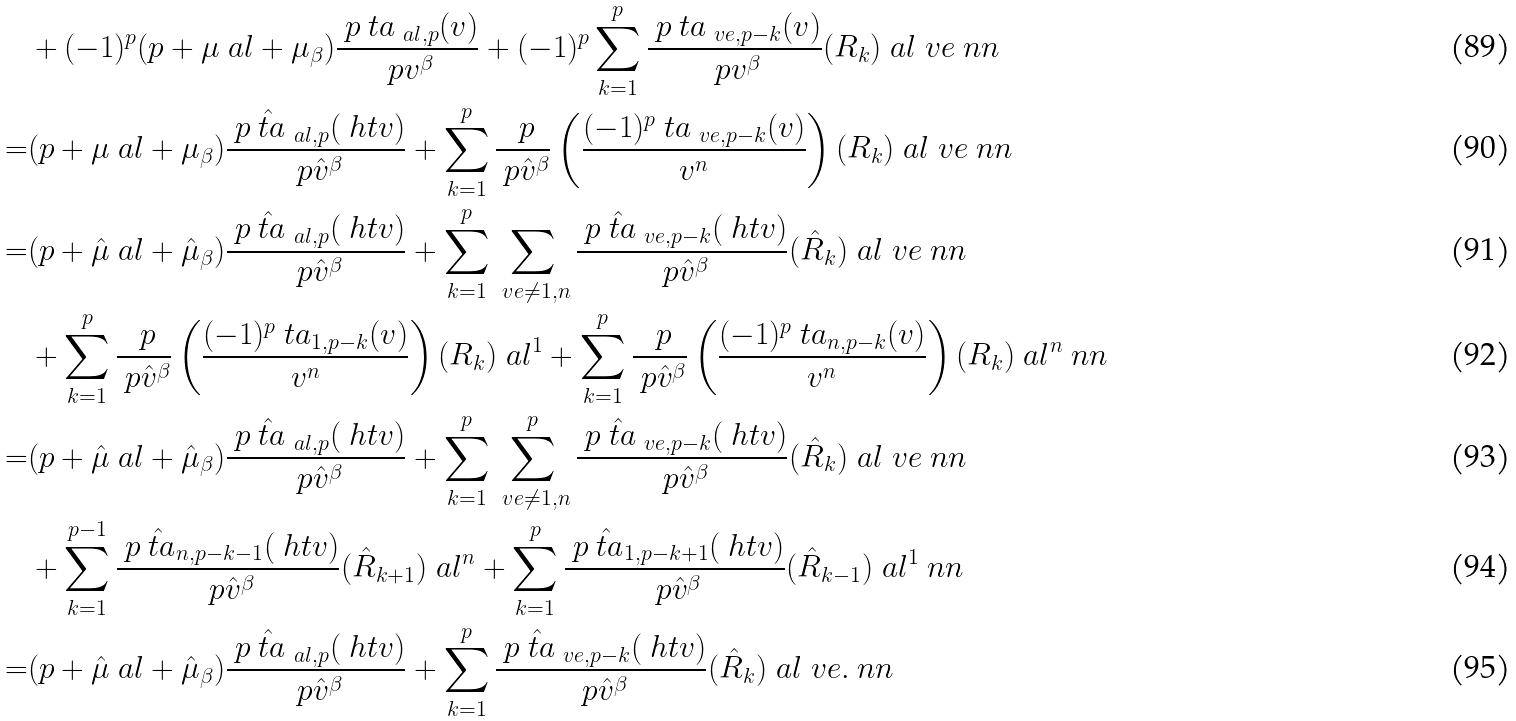Convert formula to latex. <formula><loc_0><loc_0><loc_500><loc_500>& + ( - 1 ) ^ { p } ( p + \mu _ { \ } a l + \mu _ { \beta } ) \frac { \ p \ t a _ { \ a l , p } ( v ) } { \ p v ^ { \beta } } + ( - 1 ) ^ { p } \sum _ { k = 1 } ^ { p } \frac { \ p \ t a _ { \ v e , p - k } ( v ) } { \ p v ^ { \beta } } ( R _ { k } ) _ { \ } a l ^ { \ } v e \ n n \\ = & ( p + \mu _ { \ } a l + \mu _ { \beta } ) \frac { \ p \hat { \ t a } _ { \ a l , p } ( \ h t v ) } { \ p \hat { v } ^ { \beta } } + \sum _ { k = 1 } ^ { p } \frac { \ p } { \ p \hat { v } ^ { \beta } } \left ( \frac { ( - 1 ) ^ { p } \ t a _ { \ v e , p - k } ( v ) } { v ^ { n } } \right ) ( R _ { k } ) _ { \ } a l ^ { \ } v e \ n n \\ = & ( p + \hat { \mu } _ { \ } a l + \hat { \mu } _ { \beta } ) \frac { \ p \hat { \ t a } _ { \ a l , p } ( \ h t v ) } { \ p \hat { v } ^ { \beta } } + \sum _ { k = 1 } ^ { p } \sum _ { \ v e \neq 1 , n } \frac { \ p \hat { \ t a } _ { \ v e , p - k } ( \ h t v ) } { \ p \hat { v } ^ { \beta } } ( \hat { R } _ { k } ) _ { \ } a l ^ { \ } v e \ n n \\ & + \sum _ { k = 1 } ^ { p } \frac { \ p } { \ p \hat { v } ^ { \beta } } \left ( \frac { ( - 1 ) ^ { p } \ t a _ { 1 , p - k } ( v ) } { v ^ { n } } \right ) ( R _ { k } ) _ { \ } a l ^ { 1 } + \sum _ { k = 1 } ^ { p } \frac { \ p } { \ p \hat { v } ^ { \beta } } \left ( \frac { ( - 1 ) ^ { p } \ t a _ { n , p - k } ( v ) } { v ^ { n } } \right ) ( R _ { k } ) _ { \ } a l ^ { n } \ n n \\ = & ( p + \hat { \mu } _ { \ } a l + \hat { \mu } _ { \beta } ) \frac { \ p \hat { \ t a } _ { \ a l , p } ( \ h t v ) } { \ p \hat { v } ^ { \beta } } + \sum _ { k = 1 } ^ { p } \sum _ { \ v e \neq 1 , n } ^ { p } \frac { \ p \hat { \ t a } _ { \ v e , p - k } ( \ h t v ) } { \ p \hat { v } ^ { \beta } } ( \hat { R } _ { k } ) _ { \ } a l ^ { \ } v e \ n n \\ & + \sum _ { k = 1 } ^ { p - 1 } \frac { \ p \hat { \ t a } _ { n , p - k - 1 } ( \ h t v ) } { \ p \hat { v } ^ { \beta } } ( \hat { R } _ { k + 1 } ) _ { \ } a l ^ { n } + \sum _ { k = 1 } ^ { p } \frac { \ p \hat { \ t a } _ { 1 , p - k + 1 } ( \ h t v ) } { \ p \hat { v } ^ { \beta } } ( \hat { R } _ { k - 1 } ) _ { \ } a l ^ { 1 } \ n n \\ = & ( p + \hat { \mu } _ { \ } a l + \hat { \mu } _ { \beta } ) \frac { \ p \hat { \ t a } _ { \ a l , p } ( \ h t v ) } { \ p \hat { v } ^ { \beta } } + \sum _ { k = 1 } ^ { p } \frac { \ p \hat { \ t a } _ { \ v e , p - k } ( \ h t v ) } { \ p \hat { v } ^ { \beta } } ( \hat { R } _ { k } ) _ { \ } a l ^ { \ } v e . \ n n</formula> 